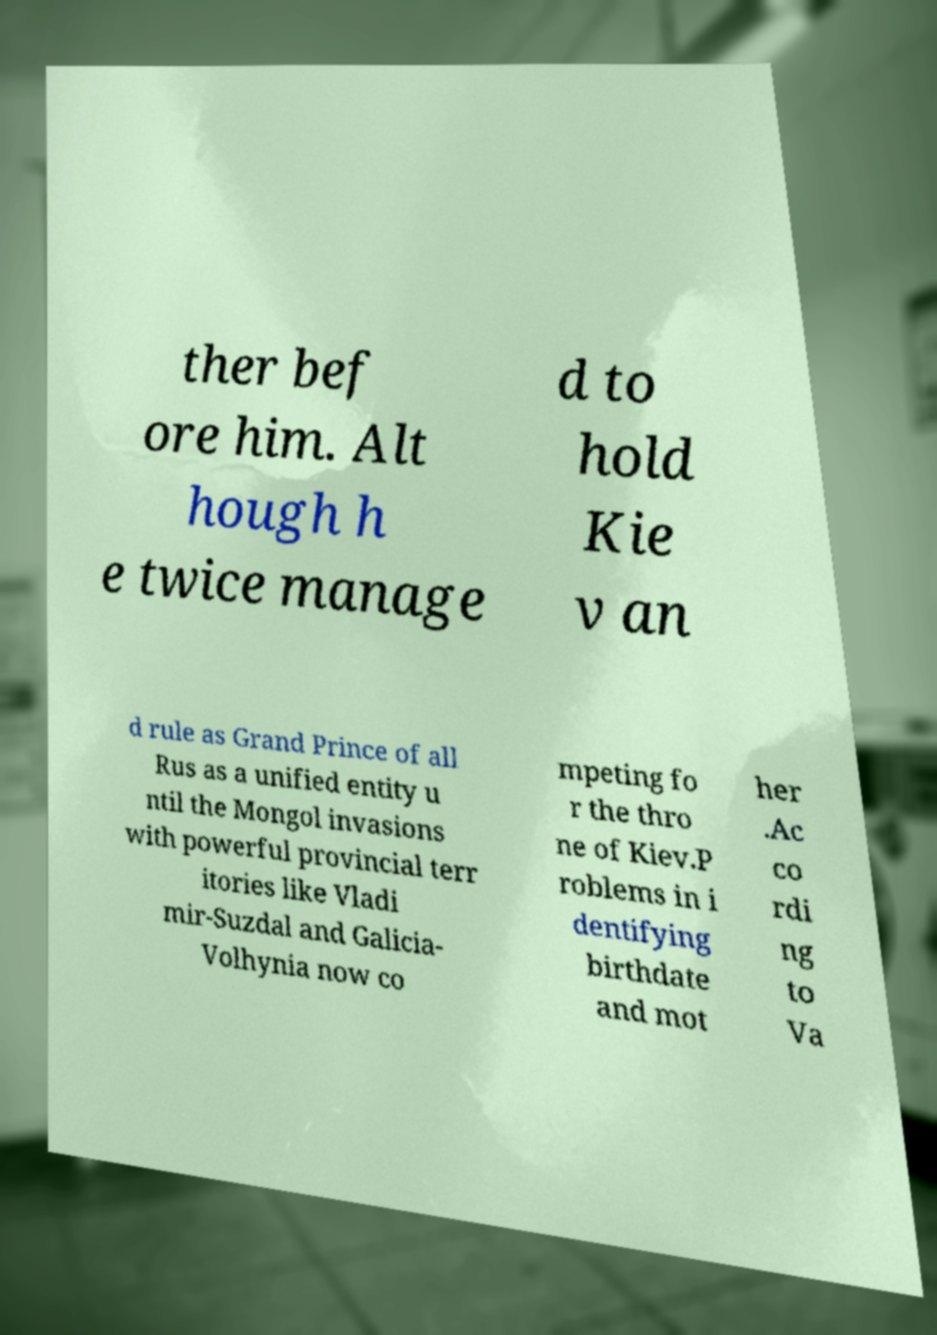Please identify and transcribe the text found in this image. ther bef ore him. Alt hough h e twice manage d to hold Kie v an d rule as Grand Prince of all Rus as a unified entity u ntil the Mongol invasions with powerful provincial terr itories like Vladi mir-Suzdal and Galicia- Volhynia now co mpeting fo r the thro ne of Kiev.P roblems in i dentifying birthdate and mot her .Ac co rdi ng to Va 